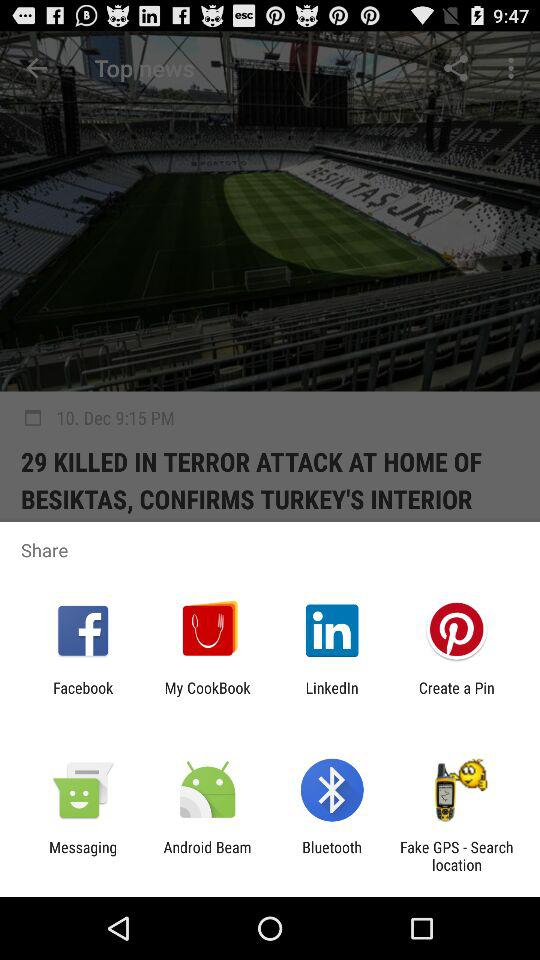How many were killed in the terror attack at the home of Besiktas? There were 29 killed in the terror attack at the home of Besiktas. 